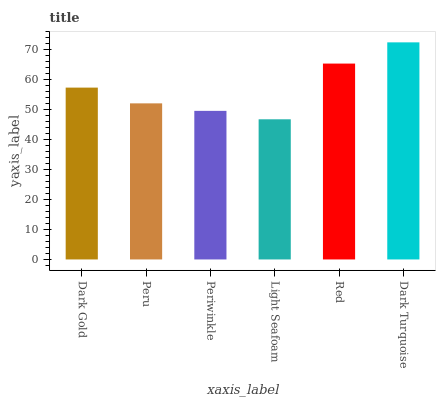Is Light Seafoam the minimum?
Answer yes or no. Yes. Is Dark Turquoise the maximum?
Answer yes or no. Yes. Is Peru the minimum?
Answer yes or no. No. Is Peru the maximum?
Answer yes or no. No. Is Dark Gold greater than Peru?
Answer yes or no. Yes. Is Peru less than Dark Gold?
Answer yes or no. Yes. Is Peru greater than Dark Gold?
Answer yes or no. No. Is Dark Gold less than Peru?
Answer yes or no. No. Is Dark Gold the high median?
Answer yes or no. Yes. Is Peru the low median?
Answer yes or no. Yes. Is Dark Turquoise the high median?
Answer yes or no. No. Is Periwinkle the low median?
Answer yes or no. No. 